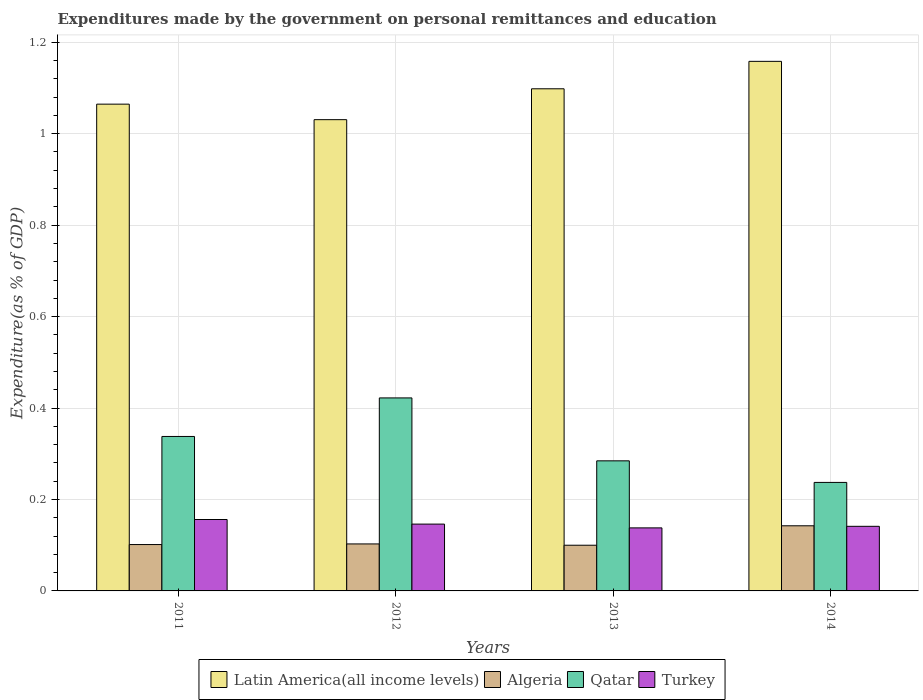How many different coloured bars are there?
Your answer should be compact. 4. Are the number of bars per tick equal to the number of legend labels?
Give a very brief answer. Yes. Are the number of bars on each tick of the X-axis equal?
Offer a terse response. Yes. How many bars are there on the 2nd tick from the right?
Offer a very short reply. 4. What is the expenditures made by the government on personal remittances and education in Algeria in 2011?
Ensure brevity in your answer.  0.1. Across all years, what is the maximum expenditures made by the government on personal remittances and education in Qatar?
Give a very brief answer. 0.42. Across all years, what is the minimum expenditures made by the government on personal remittances and education in Turkey?
Your answer should be compact. 0.14. What is the total expenditures made by the government on personal remittances and education in Turkey in the graph?
Your answer should be very brief. 0.58. What is the difference between the expenditures made by the government on personal remittances and education in Latin America(all income levels) in 2011 and that in 2014?
Your answer should be very brief. -0.09. What is the difference between the expenditures made by the government on personal remittances and education in Latin America(all income levels) in 2012 and the expenditures made by the government on personal remittances and education in Algeria in 2013?
Offer a very short reply. 0.93. What is the average expenditures made by the government on personal remittances and education in Turkey per year?
Offer a very short reply. 0.15. In the year 2013, what is the difference between the expenditures made by the government on personal remittances and education in Turkey and expenditures made by the government on personal remittances and education in Qatar?
Your response must be concise. -0.15. What is the ratio of the expenditures made by the government on personal remittances and education in Turkey in 2011 to that in 2014?
Your answer should be compact. 1.11. What is the difference between the highest and the second highest expenditures made by the government on personal remittances and education in Turkey?
Give a very brief answer. 0.01. What is the difference between the highest and the lowest expenditures made by the government on personal remittances and education in Latin America(all income levels)?
Provide a short and direct response. 0.13. In how many years, is the expenditures made by the government on personal remittances and education in Latin America(all income levels) greater than the average expenditures made by the government on personal remittances and education in Latin America(all income levels) taken over all years?
Ensure brevity in your answer.  2. Is the sum of the expenditures made by the government on personal remittances and education in Turkey in 2013 and 2014 greater than the maximum expenditures made by the government on personal remittances and education in Qatar across all years?
Keep it short and to the point. No. Is it the case that in every year, the sum of the expenditures made by the government on personal remittances and education in Latin America(all income levels) and expenditures made by the government on personal remittances and education in Turkey is greater than the sum of expenditures made by the government on personal remittances and education in Qatar and expenditures made by the government on personal remittances and education in Algeria?
Your response must be concise. Yes. What does the 4th bar from the left in 2014 represents?
Make the answer very short. Turkey. What does the 2nd bar from the right in 2012 represents?
Provide a short and direct response. Qatar. Is it the case that in every year, the sum of the expenditures made by the government on personal remittances and education in Qatar and expenditures made by the government on personal remittances and education in Turkey is greater than the expenditures made by the government on personal remittances and education in Latin America(all income levels)?
Keep it short and to the point. No. How many years are there in the graph?
Make the answer very short. 4. What is the difference between two consecutive major ticks on the Y-axis?
Your response must be concise. 0.2. Does the graph contain any zero values?
Provide a short and direct response. No. Where does the legend appear in the graph?
Your answer should be compact. Bottom center. What is the title of the graph?
Your response must be concise. Expenditures made by the government on personal remittances and education. What is the label or title of the X-axis?
Ensure brevity in your answer.  Years. What is the label or title of the Y-axis?
Your answer should be compact. Expenditure(as % of GDP). What is the Expenditure(as % of GDP) in Latin America(all income levels) in 2011?
Provide a succinct answer. 1.06. What is the Expenditure(as % of GDP) of Algeria in 2011?
Your response must be concise. 0.1. What is the Expenditure(as % of GDP) of Qatar in 2011?
Provide a succinct answer. 0.34. What is the Expenditure(as % of GDP) in Turkey in 2011?
Your answer should be very brief. 0.16. What is the Expenditure(as % of GDP) of Latin America(all income levels) in 2012?
Give a very brief answer. 1.03. What is the Expenditure(as % of GDP) of Algeria in 2012?
Give a very brief answer. 0.1. What is the Expenditure(as % of GDP) in Qatar in 2012?
Your answer should be compact. 0.42. What is the Expenditure(as % of GDP) in Turkey in 2012?
Keep it short and to the point. 0.15. What is the Expenditure(as % of GDP) in Latin America(all income levels) in 2013?
Provide a short and direct response. 1.1. What is the Expenditure(as % of GDP) of Algeria in 2013?
Keep it short and to the point. 0.1. What is the Expenditure(as % of GDP) in Qatar in 2013?
Keep it short and to the point. 0.28. What is the Expenditure(as % of GDP) of Turkey in 2013?
Keep it short and to the point. 0.14. What is the Expenditure(as % of GDP) of Latin America(all income levels) in 2014?
Ensure brevity in your answer.  1.16. What is the Expenditure(as % of GDP) in Algeria in 2014?
Your answer should be compact. 0.14. What is the Expenditure(as % of GDP) in Qatar in 2014?
Offer a very short reply. 0.24. What is the Expenditure(as % of GDP) of Turkey in 2014?
Your response must be concise. 0.14. Across all years, what is the maximum Expenditure(as % of GDP) in Latin America(all income levels)?
Your answer should be very brief. 1.16. Across all years, what is the maximum Expenditure(as % of GDP) of Algeria?
Your response must be concise. 0.14. Across all years, what is the maximum Expenditure(as % of GDP) of Qatar?
Keep it short and to the point. 0.42. Across all years, what is the maximum Expenditure(as % of GDP) of Turkey?
Give a very brief answer. 0.16. Across all years, what is the minimum Expenditure(as % of GDP) of Latin America(all income levels)?
Make the answer very short. 1.03. Across all years, what is the minimum Expenditure(as % of GDP) of Algeria?
Offer a terse response. 0.1. Across all years, what is the minimum Expenditure(as % of GDP) in Qatar?
Ensure brevity in your answer.  0.24. Across all years, what is the minimum Expenditure(as % of GDP) of Turkey?
Offer a terse response. 0.14. What is the total Expenditure(as % of GDP) in Latin America(all income levels) in the graph?
Offer a very short reply. 4.35. What is the total Expenditure(as % of GDP) of Algeria in the graph?
Your answer should be very brief. 0.45. What is the total Expenditure(as % of GDP) in Qatar in the graph?
Your answer should be very brief. 1.28. What is the total Expenditure(as % of GDP) of Turkey in the graph?
Provide a short and direct response. 0.58. What is the difference between the Expenditure(as % of GDP) in Latin America(all income levels) in 2011 and that in 2012?
Provide a succinct answer. 0.03. What is the difference between the Expenditure(as % of GDP) of Algeria in 2011 and that in 2012?
Your answer should be compact. -0. What is the difference between the Expenditure(as % of GDP) of Qatar in 2011 and that in 2012?
Give a very brief answer. -0.08. What is the difference between the Expenditure(as % of GDP) of Latin America(all income levels) in 2011 and that in 2013?
Make the answer very short. -0.03. What is the difference between the Expenditure(as % of GDP) in Algeria in 2011 and that in 2013?
Keep it short and to the point. 0. What is the difference between the Expenditure(as % of GDP) of Qatar in 2011 and that in 2013?
Provide a short and direct response. 0.05. What is the difference between the Expenditure(as % of GDP) of Turkey in 2011 and that in 2013?
Provide a short and direct response. 0.02. What is the difference between the Expenditure(as % of GDP) of Latin America(all income levels) in 2011 and that in 2014?
Offer a terse response. -0.09. What is the difference between the Expenditure(as % of GDP) of Algeria in 2011 and that in 2014?
Keep it short and to the point. -0.04. What is the difference between the Expenditure(as % of GDP) in Qatar in 2011 and that in 2014?
Provide a succinct answer. 0.1. What is the difference between the Expenditure(as % of GDP) of Turkey in 2011 and that in 2014?
Offer a terse response. 0.01. What is the difference between the Expenditure(as % of GDP) of Latin America(all income levels) in 2012 and that in 2013?
Make the answer very short. -0.07. What is the difference between the Expenditure(as % of GDP) in Algeria in 2012 and that in 2013?
Provide a succinct answer. 0. What is the difference between the Expenditure(as % of GDP) in Qatar in 2012 and that in 2013?
Give a very brief answer. 0.14. What is the difference between the Expenditure(as % of GDP) in Turkey in 2012 and that in 2013?
Your answer should be compact. 0.01. What is the difference between the Expenditure(as % of GDP) in Latin America(all income levels) in 2012 and that in 2014?
Provide a succinct answer. -0.13. What is the difference between the Expenditure(as % of GDP) in Algeria in 2012 and that in 2014?
Give a very brief answer. -0.04. What is the difference between the Expenditure(as % of GDP) in Qatar in 2012 and that in 2014?
Keep it short and to the point. 0.18. What is the difference between the Expenditure(as % of GDP) in Turkey in 2012 and that in 2014?
Ensure brevity in your answer.  0. What is the difference between the Expenditure(as % of GDP) of Latin America(all income levels) in 2013 and that in 2014?
Provide a succinct answer. -0.06. What is the difference between the Expenditure(as % of GDP) in Algeria in 2013 and that in 2014?
Make the answer very short. -0.04. What is the difference between the Expenditure(as % of GDP) in Qatar in 2013 and that in 2014?
Make the answer very short. 0.05. What is the difference between the Expenditure(as % of GDP) of Turkey in 2013 and that in 2014?
Ensure brevity in your answer.  -0. What is the difference between the Expenditure(as % of GDP) in Latin America(all income levels) in 2011 and the Expenditure(as % of GDP) in Algeria in 2012?
Provide a succinct answer. 0.96. What is the difference between the Expenditure(as % of GDP) in Latin America(all income levels) in 2011 and the Expenditure(as % of GDP) in Qatar in 2012?
Offer a very short reply. 0.64. What is the difference between the Expenditure(as % of GDP) in Latin America(all income levels) in 2011 and the Expenditure(as % of GDP) in Turkey in 2012?
Ensure brevity in your answer.  0.92. What is the difference between the Expenditure(as % of GDP) of Algeria in 2011 and the Expenditure(as % of GDP) of Qatar in 2012?
Your answer should be very brief. -0.32. What is the difference between the Expenditure(as % of GDP) of Algeria in 2011 and the Expenditure(as % of GDP) of Turkey in 2012?
Provide a short and direct response. -0.04. What is the difference between the Expenditure(as % of GDP) of Qatar in 2011 and the Expenditure(as % of GDP) of Turkey in 2012?
Make the answer very short. 0.19. What is the difference between the Expenditure(as % of GDP) of Latin America(all income levels) in 2011 and the Expenditure(as % of GDP) of Algeria in 2013?
Provide a succinct answer. 0.96. What is the difference between the Expenditure(as % of GDP) of Latin America(all income levels) in 2011 and the Expenditure(as % of GDP) of Qatar in 2013?
Your response must be concise. 0.78. What is the difference between the Expenditure(as % of GDP) in Latin America(all income levels) in 2011 and the Expenditure(as % of GDP) in Turkey in 2013?
Your answer should be compact. 0.93. What is the difference between the Expenditure(as % of GDP) of Algeria in 2011 and the Expenditure(as % of GDP) of Qatar in 2013?
Ensure brevity in your answer.  -0.18. What is the difference between the Expenditure(as % of GDP) in Algeria in 2011 and the Expenditure(as % of GDP) in Turkey in 2013?
Provide a short and direct response. -0.04. What is the difference between the Expenditure(as % of GDP) of Qatar in 2011 and the Expenditure(as % of GDP) of Turkey in 2013?
Offer a terse response. 0.2. What is the difference between the Expenditure(as % of GDP) in Latin America(all income levels) in 2011 and the Expenditure(as % of GDP) in Algeria in 2014?
Keep it short and to the point. 0.92. What is the difference between the Expenditure(as % of GDP) of Latin America(all income levels) in 2011 and the Expenditure(as % of GDP) of Qatar in 2014?
Ensure brevity in your answer.  0.83. What is the difference between the Expenditure(as % of GDP) of Latin America(all income levels) in 2011 and the Expenditure(as % of GDP) of Turkey in 2014?
Offer a terse response. 0.92. What is the difference between the Expenditure(as % of GDP) in Algeria in 2011 and the Expenditure(as % of GDP) in Qatar in 2014?
Offer a very short reply. -0.14. What is the difference between the Expenditure(as % of GDP) in Algeria in 2011 and the Expenditure(as % of GDP) in Turkey in 2014?
Your answer should be compact. -0.04. What is the difference between the Expenditure(as % of GDP) of Qatar in 2011 and the Expenditure(as % of GDP) of Turkey in 2014?
Your answer should be very brief. 0.2. What is the difference between the Expenditure(as % of GDP) in Latin America(all income levels) in 2012 and the Expenditure(as % of GDP) in Algeria in 2013?
Your response must be concise. 0.93. What is the difference between the Expenditure(as % of GDP) of Latin America(all income levels) in 2012 and the Expenditure(as % of GDP) of Qatar in 2013?
Give a very brief answer. 0.75. What is the difference between the Expenditure(as % of GDP) in Latin America(all income levels) in 2012 and the Expenditure(as % of GDP) in Turkey in 2013?
Your response must be concise. 0.89. What is the difference between the Expenditure(as % of GDP) of Algeria in 2012 and the Expenditure(as % of GDP) of Qatar in 2013?
Make the answer very short. -0.18. What is the difference between the Expenditure(as % of GDP) in Algeria in 2012 and the Expenditure(as % of GDP) in Turkey in 2013?
Provide a short and direct response. -0.04. What is the difference between the Expenditure(as % of GDP) in Qatar in 2012 and the Expenditure(as % of GDP) in Turkey in 2013?
Ensure brevity in your answer.  0.28. What is the difference between the Expenditure(as % of GDP) in Latin America(all income levels) in 2012 and the Expenditure(as % of GDP) in Algeria in 2014?
Offer a terse response. 0.89. What is the difference between the Expenditure(as % of GDP) in Latin America(all income levels) in 2012 and the Expenditure(as % of GDP) in Qatar in 2014?
Your response must be concise. 0.79. What is the difference between the Expenditure(as % of GDP) in Latin America(all income levels) in 2012 and the Expenditure(as % of GDP) in Turkey in 2014?
Your answer should be very brief. 0.89. What is the difference between the Expenditure(as % of GDP) of Algeria in 2012 and the Expenditure(as % of GDP) of Qatar in 2014?
Make the answer very short. -0.13. What is the difference between the Expenditure(as % of GDP) of Algeria in 2012 and the Expenditure(as % of GDP) of Turkey in 2014?
Offer a terse response. -0.04. What is the difference between the Expenditure(as % of GDP) of Qatar in 2012 and the Expenditure(as % of GDP) of Turkey in 2014?
Keep it short and to the point. 0.28. What is the difference between the Expenditure(as % of GDP) of Latin America(all income levels) in 2013 and the Expenditure(as % of GDP) of Algeria in 2014?
Provide a short and direct response. 0.96. What is the difference between the Expenditure(as % of GDP) of Latin America(all income levels) in 2013 and the Expenditure(as % of GDP) of Qatar in 2014?
Provide a succinct answer. 0.86. What is the difference between the Expenditure(as % of GDP) of Latin America(all income levels) in 2013 and the Expenditure(as % of GDP) of Turkey in 2014?
Provide a succinct answer. 0.96. What is the difference between the Expenditure(as % of GDP) in Algeria in 2013 and the Expenditure(as % of GDP) in Qatar in 2014?
Your answer should be compact. -0.14. What is the difference between the Expenditure(as % of GDP) in Algeria in 2013 and the Expenditure(as % of GDP) in Turkey in 2014?
Ensure brevity in your answer.  -0.04. What is the difference between the Expenditure(as % of GDP) in Qatar in 2013 and the Expenditure(as % of GDP) in Turkey in 2014?
Provide a short and direct response. 0.14. What is the average Expenditure(as % of GDP) in Latin America(all income levels) per year?
Keep it short and to the point. 1.09. What is the average Expenditure(as % of GDP) in Algeria per year?
Make the answer very short. 0.11. What is the average Expenditure(as % of GDP) in Qatar per year?
Your answer should be compact. 0.32. What is the average Expenditure(as % of GDP) of Turkey per year?
Provide a short and direct response. 0.15. In the year 2011, what is the difference between the Expenditure(as % of GDP) in Latin America(all income levels) and Expenditure(as % of GDP) in Algeria?
Ensure brevity in your answer.  0.96. In the year 2011, what is the difference between the Expenditure(as % of GDP) of Latin America(all income levels) and Expenditure(as % of GDP) of Qatar?
Make the answer very short. 0.73. In the year 2011, what is the difference between the Expenditure(as % of GDP) in Latin America(all income levels) and Expenditure(as % of GDP) in Turkey?
Offer a very short reply. 0.91. In the year 2011, what is the difference between the Expenditure(as % of GDP) of Algeria and Expenditure(as % of GDP) of Qatar?
Offer a terse response. -0.24. In the year 2011, what is the difference between the Expenditure(as % of GDP) of Algeria and Expenditure(as % of GDP) of Turkey?
Provide a succinct answer. -0.05. In the year 2011, what is the difference between the Expenditure(as % of GDP) of Qatar and Expenditure(as % of GDP) of Turkey?
Offer a very short reply. 0.18. In the year 2012, what is the difference between the Expenditure(as % of GDP) in Latin America(all income levels) and Expenditure(as % of GDP) in Algeria?
Your answer should be compact. 0.93. In the year 2012, what is the difference between the Expenditure(as % of GDP) of Latin America(all income levels) and Expenditure(as % of GDP) of Qatar?
Keep it short and to the point. 0.61. In the year 2012, what is the difference between the Expenditure(as % of GDP) in Latin America(all income levels) and Expenditure(as % of GDP) in Turkey?
Keep it short and to the point. 0.88. In the year 2012, what is the difference between the Expenditure(as % of GDP) of Algeria and Expenditure(as % of GDP) of Qatar?
Offer a very short reply. -0.32. In the year 2012, what is the difference between the Expenditure(as % of GDP) of Algeria and Expenditure(as % of GDP) of Turkey?
Give a very brief answer. -0.04. In the year 2012, what is the difference between the Expenditure(as % of GDP) in Qatar and Expenditure(as % of GDP) in Turkey?
Give a very brief answer. 0.28. In the year 2013, what is the difference between the Expenditure(as % of GDP) in Latin America(all income levels) and Expenditure(as % of GDP) in Qatar?
Give a very brief answer. 0.81. In the year 2013, what is the difference between the Expenditure(as % of GDP) of Latin America(all income levels) and Expenditure(as % of GDP) of Turkey?
Provide a short and direct response. 0.96. In the year 2013, what is the difference between the Expenditure(as % of GDP) of Algeria and Expenditure(as % of GDP) of Qatar?
Offer a very short reply. -0.18. In the year 2013, what is the difference between the Expenditure(as % of GDP) in Algeria and Expenditure(as % of GDP) in Turkey?
Your response must be concise. -0.04. In the year 2013, what is the difference between the Expenditure(as % of GDP) in Qatar and Expenditure(as % of GDP) in Turkey?
Offer a very short reply. 0.15. In the year 2014, what is the difference between the Expenditure(as % of GDP) of Latin America(all income levels) and Expenditure(as % of GDP) of Algeria?
Your answer should be very brief. 1.02. In the year 2014, what is the difference between the Expenditure(as % of GDP) in Latin America(all income levels) and Expenditure(as % of GDP) in Qatar?
Keep it short and to the point. 0.92. In the year 2014, what is the difference between the Expenditure(as % of GDP) of Algeria and Expenditure(as % of GDP) of Qatar?
Your answer should be compact. -0.09. In the year 2014, what is the difference between the Expenditure(as % of GDP) in Algeria and Expenditure(as % of GDP) in Turkey?
Offer a very short reply. 0. In the year 2014, what is the difference between the Expenditure(as % of GDP) of Qatar and Expenditure(as % of GDP) of Turkey?
Offer a terse response. 0.1. What is the ratio of the Expenditure(as % of GDP) in Latin America(all income levels) in 2011 to that in 2012?
Ensure brevity in your answer.  1.03. What is the ratio of the Expenditure(as % of GDP) of Algeria in 2011 to that in 2012?
Your answer should be compact. 0.99. What is the ratio of the Expenditure(as % of GDP) of Qatar in 2011 to that in 2012?
Ensure brevity in your answer.  0.8. What is the ratio of the Expenditure(as % of GDP) in Turkey in 2011 to that in 2012?
Make the answer very short. 1.07. What is the ratio of the Expenditure(as % of GDP) of Latin America(all income levels) in 2011 to that in 2013?
Provide a succinct answer. 0.97. What is the ratio of the Expenditure(as % of GDP) in Algeria in 2011 to that in 2013?
Provide a short and direct response. 1.01. What is the ratio of the Expenditure(as % of GDP) of Qatar in 2011 to that in 2013?
Your answer should be very brief. 1.19. What is the ratio of the Expenditure(as % of GDP) in Turkey in 2011 to that in 2013?
Keep it short and to the point. 1.13. What is the ratio of the Expenditure(as % of GDP) in Latin America(all income levels) in 2011 to that in 2014?
Offer a terse response. 0.92. What is the ratio of the Expenditure(as % of GDP) in Algeria in 2011 to that in 2014?
Offer a terse response. 0.71. What is the ratio of the Expenditure(as % of GDP) of Qatar in 2011 to that in 2014?
Give a very brief answer. 1.42. What is the ratio of the Expenditure(as % of GDP) of Turkey in 2011 to that in 2014?
Your answer should be very brief. 1.11. What is the ratio of the Expenditure(as % of GDP) of Latin America(all income levels) in 2012 to that in 2013?
Ensure brevity in your answer.  0.94. What is the ratio of the Expenditure(as % of GDP) of Algeria in 2012 to that in 2013?
Provide a succinct answer. 1.03. What is the ratio of the Expenditure(as % of GDP) of Qatar in 2012 to that in 2013?
Give a very brief answer. 1.48. What is the ratio of the Expenditure(as % of GDP) in Turkey in 2012 to that in 2013?
Keep it short and to the point. 1.06. What is the ratio of the Expenditure(as % of GDP) of Latin America(all income levels) in 2012 to that in 2014?
Ensure brevity in your answer.  0.89. What is the ratio of the Expenditure(as % of GDP) of Algeria in 2012 to that in 2014?
Ensure brevity in your answer.  0.72. What is the ratio of the Expenditure(as % of GDP) in Qatar in 2012 to that in 2014?
Give a very brief answer. 1.78. What is the ratio of the Expenditure(as % of GDP) in Turkey in 2012 to that in 2014?
Provide a short and direct response. 1.03. What is the ratio of the Expenditure(as % of GDP) in Latin America(all income levels) in 2013 to that in 2014?
Make the answer very short. 0.95. What is the ratio of the Expenditure(as % of GDP) in Algeria in 2013 to that in 2014?
Provide a short and direct response. 0.7. What is the ratio of the Expenditure(as % of GDP) in Qatar in 2013 to that in 2014?
Your answer should be very brief. 1.2. What is the ratio of the Expenditure(as % of GDP) of Turkey in 2013 to that in 2014?
Offer a very short reply. 0.98. What is the difference between the highest and the second highest Expenditure(as % of GDP) in Latin America(all income levels)?
Your response must be concise. 0.06. What is the difference between the highest and the second highest Expenditure(as % of GDP) in Algeria?
Offer a terse response. 0.04. What is the difference between the highest and the second highest Expenditure(as % of GDP) of Qatar?
Keep it short and to the point. 0.08. What is the difference between the highest and the lowest Expenditure(as % of GDP) in Latin America(all income levels)?
Give a very brief answer. 0.13. What is the difference between the highest and the lowest Expenditure(as % of GDP) in Algeria?
Offer a terse response. 0.04. What is the difference between the highest and the lowest Expenditure(as % of GDP) in Qatar?
Offer a very short reply. 0.18. What is the difference between the highest and the lowest Expenditure(as % of GDP) in Turkey?
Provide a short and direct response. 0.02. 